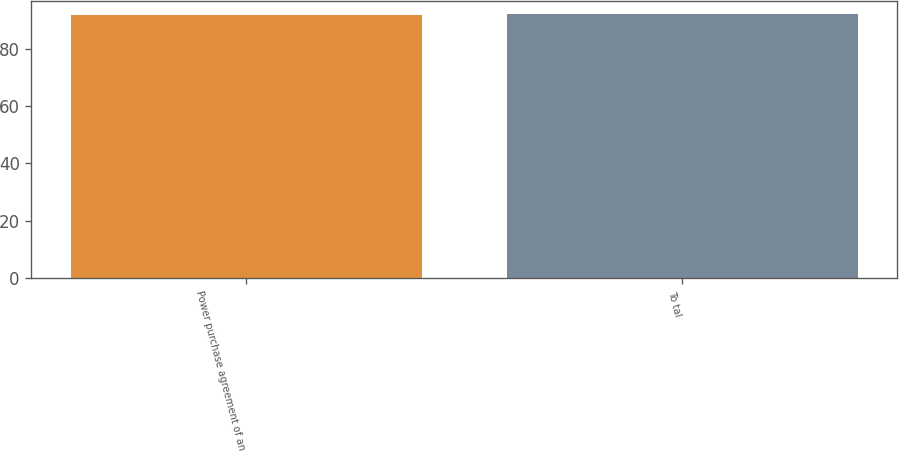<chart> <loc_0><loc_0><loc_500><loc_500><bar_chart><fcel>Power purchase agreement of an<fcel>To tal<nl><fcel>92<fcel>92.1<nl></chart> 